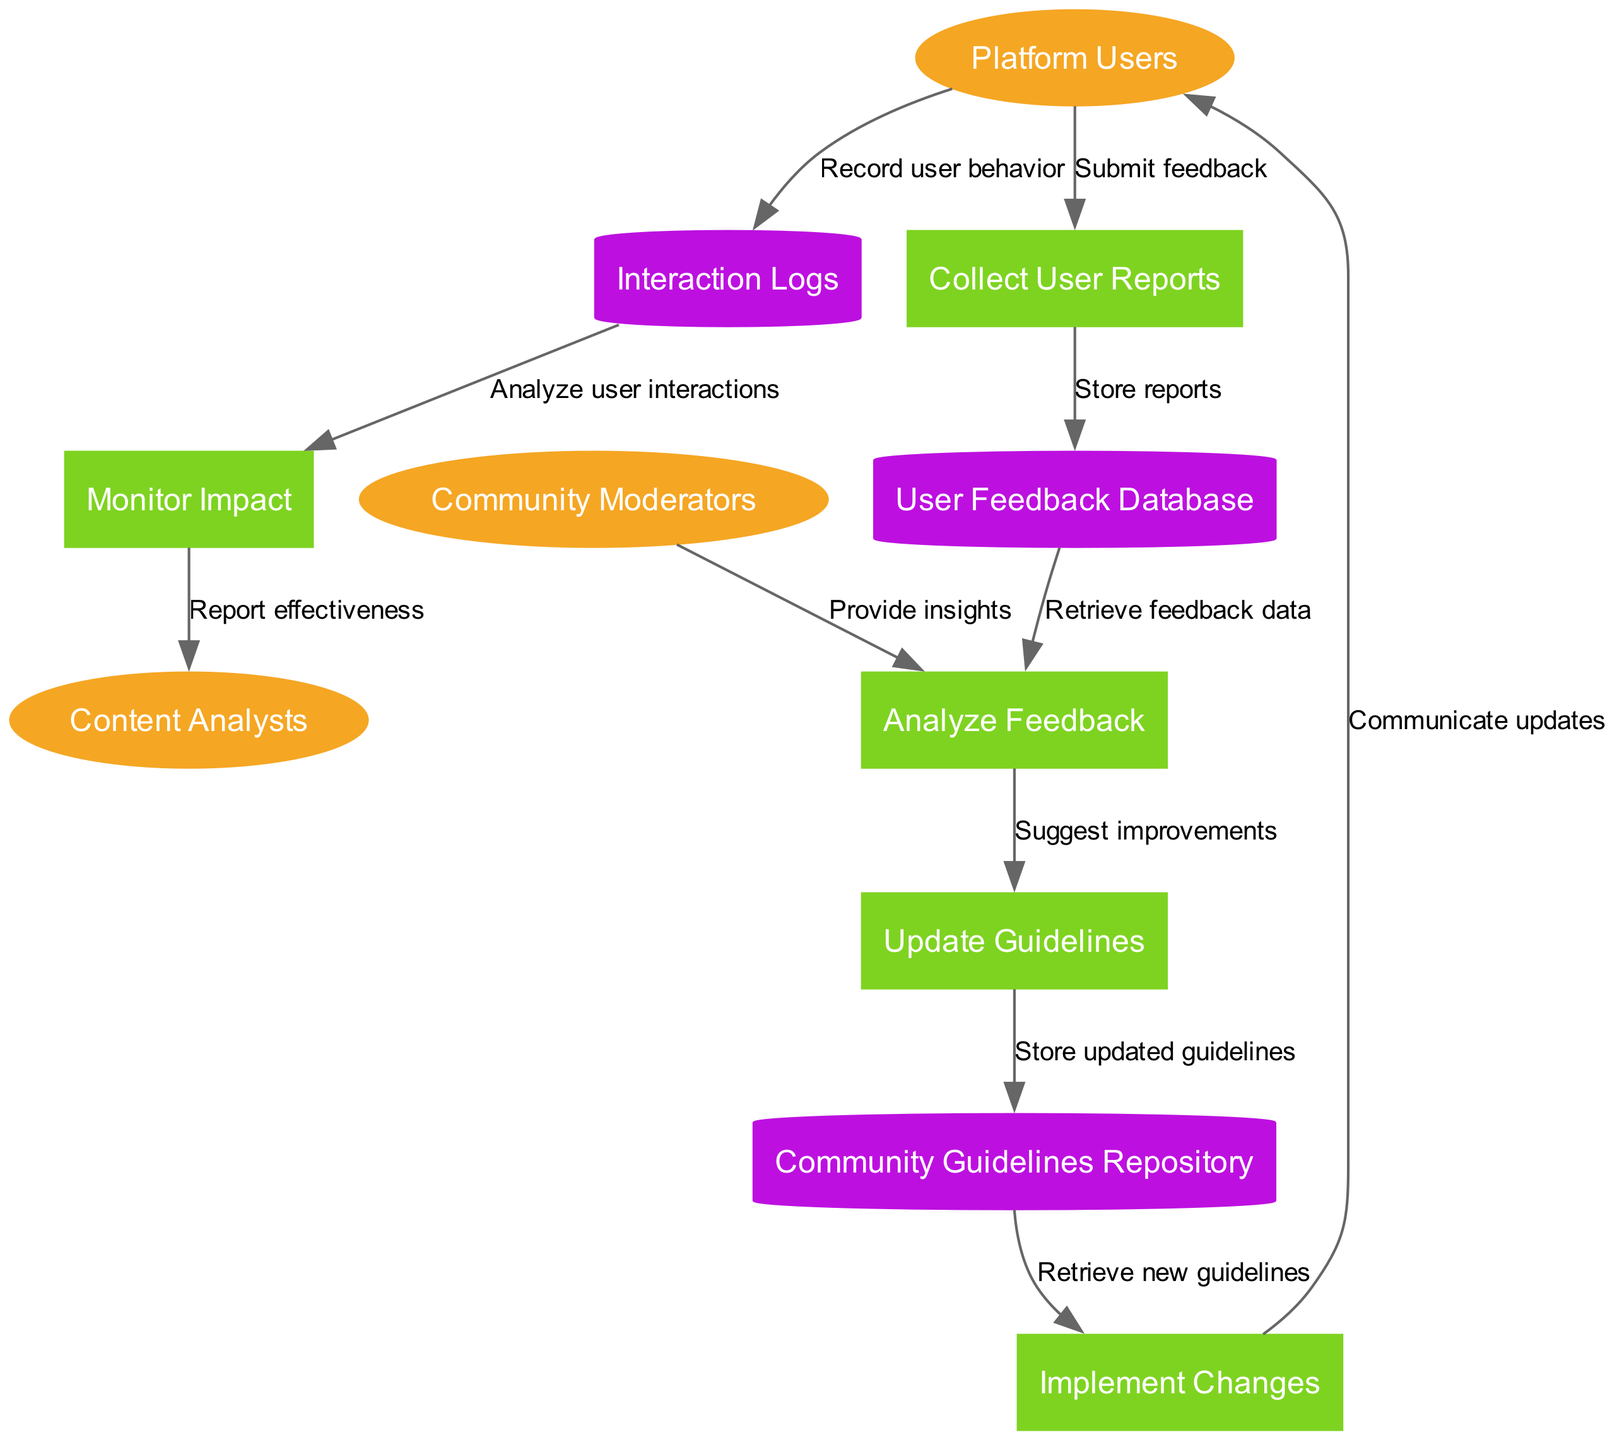What are the external entities in the diagram? The external entities are clearly labeled in the diagram and include "Platform Users," "Community Moderators," and "Content Analysts." These entities represent the different stakeholders involved in the feedback loop.
Answer: Platform Users, Community Moderators, Content Analysts How many processes are depicted in the diagram? The processes in the diagram include "Collect User Reports," "Analyze Feedback," "Update Guidelines," "Implement Changes," and "Monitor Impact." By counting these processes, we can determine that there are five.
Answer: 5 What does the "Collect User Reports" process receive from the "Platform Users"? The diagram indicates that the "Collect User Reports" process receives "Submit feedback" from the "Platform Users." This flow captures the action taken by users to report their feedback.
Answer: Submit feedback Where do the updated guidelines get stored? The diagram shows that the updated guidelines are stored in the "Community Guidelines Repository" as indicated by the flow from "Update Guidelines" to "Community Guidelines Repository."
Answer: Community Guidelines Repository What flow goes from "Interaction Logs" to "Monitor Impact"? The diagram shows there is a data flow labeled "Analyze user interactions" that goes from "Interaction Logs" to "Monitor Impact." This flow signifies how user behavior is assessed.
Answer: Analyze user interactions Which process communicates updates back to the "Platform Users"? According to the diagram, the "Implement Changes" process communicates updates back to "Platform Users," facilitating the feedback loop by informing users of revisions made.
Answer: Communicate updates What is the output of the "Analyze Feedback" process? The "Analyze Feedback" process delivers "Suggest improvements" to the "Update Guidelines" process as depicted in the flow. This indicates that feedback analysis results in recommendations for changes.
Answer: Suggest improvements How do the "Community Moderators" contribute to the "Analyze Feedback" process? The "Community Moderators" provide insights to the "Analyze Feedback" process, which enhances the understanding of user feedback, making their role integral in the analysis.
Answer: Provide insights What is the purpose of the "Monitor Impact" process? The purpose of the "Monitor Impact" process is to "Report effectiveness," which reflects its role in assessing how well the changes made after feedback have been received and their overall impact.
Answer: Report effectiveness 